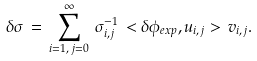<formula> <loc_0><loc_0><loc_500><loc_500>\delta \sigma \, = \, \sum _ { i = 1 , \, j = 0 } ^ { \infty } \, \sigma _ { i , j } ^ { - 1 } \, < \delta \phi _ { e x p } , u _ { i , j } > \, v _ { i , j } .</formula> 